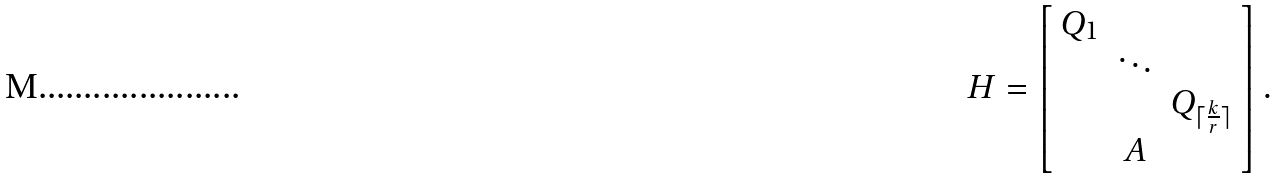Convert formula to latex. <formula><loc_0><loc_0><loc_500><loc_500>H = \left [ \begin{array} { c c c } Q _ { 1 } & & \\ & \ddots & \\ & & Q _ { \lceil \frac { k } { r } \rceil } \\ & A & \end{array} \right ] .</formula> 